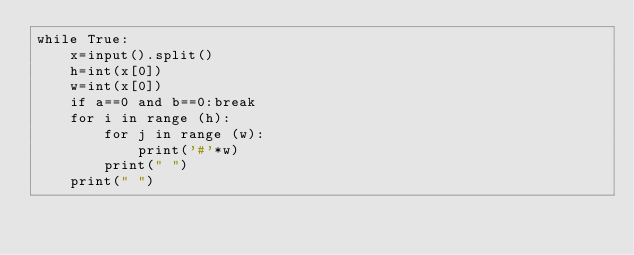<code> <loc_0><loc_0><loc_500><loc_500><_Python_>while True:
    x=input().split()
    h=int(x[0])
    w=int(x[0])
    if a==0 and b==0:break
    for i in range (h):
        for j in range (w):
            print('#'*w)
        print(" ")
    print(" ")
</code> 